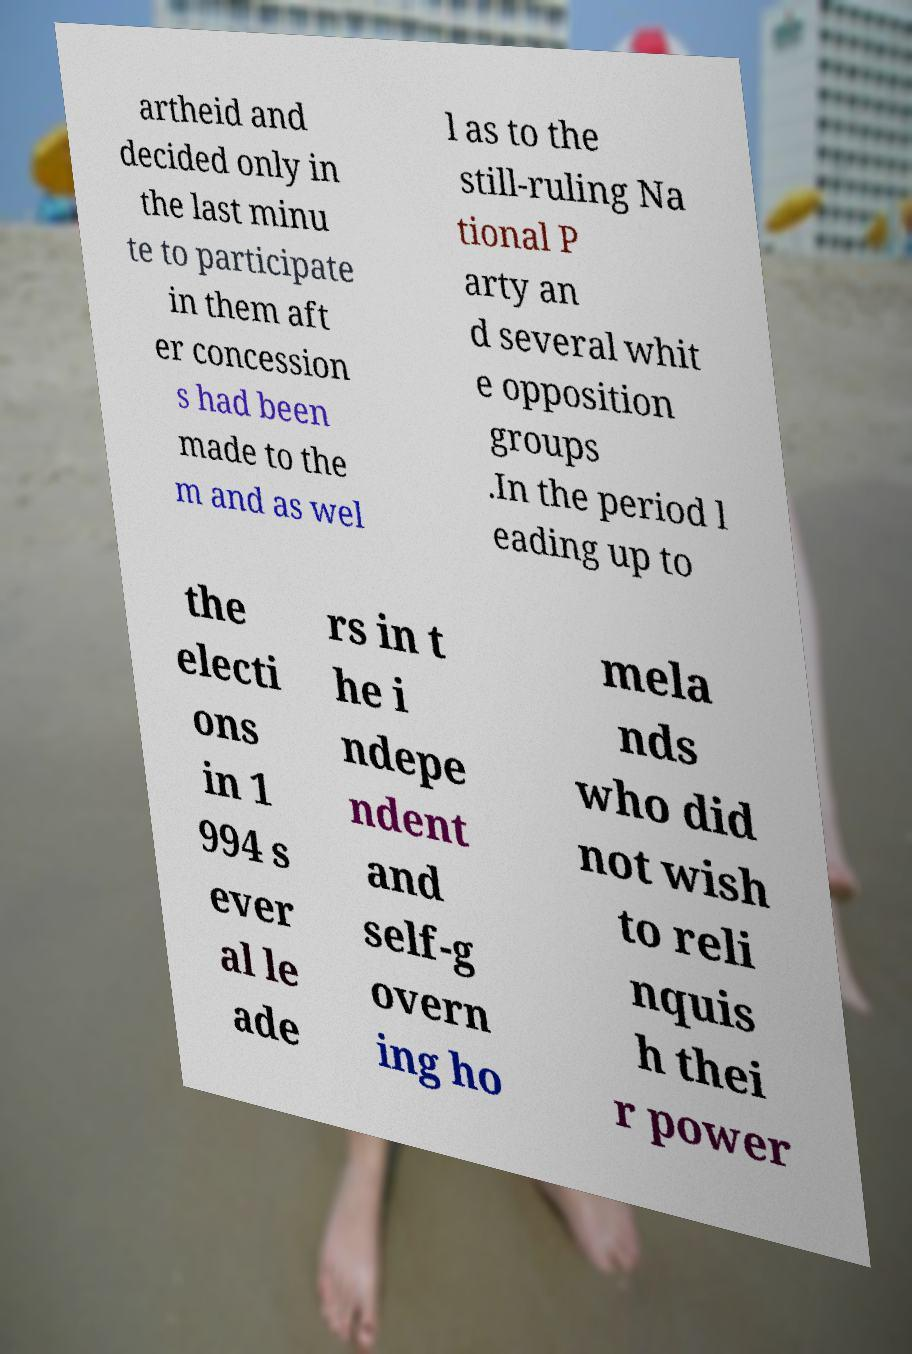Could you extract and type out the text from this image? artheid and decided only in the last minu te to participate in them aft er concession s had been made to the m and as wel l as to the still-ruling Na tional P arty an d several whit e opposition groups .In the period l eading up to the electi ons in 1 994 s ever al le ade rs in t he i ndepe ndent and self-g overn ing ho mela nds who did not wish to reli nquis h thei r power 